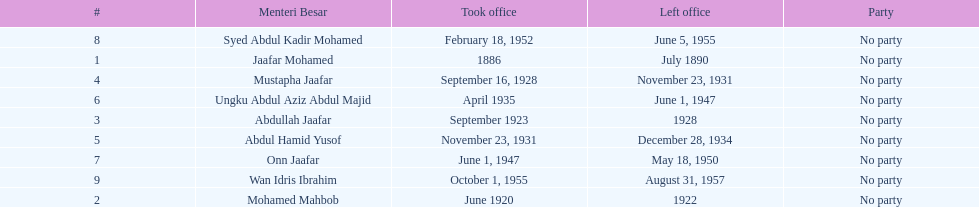Other than abullah jaafar, name someone with the same last name. Mustapha Jaafar. 